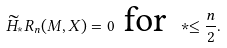Convert formula to latex. <formula><loc_0><loc_0><loc_500><loc_500>\widetilde { H } _ { * } R _ { n } ( M , X ) = 0 \text { for } * \leq \frac { n } { 2 } .</formula> 